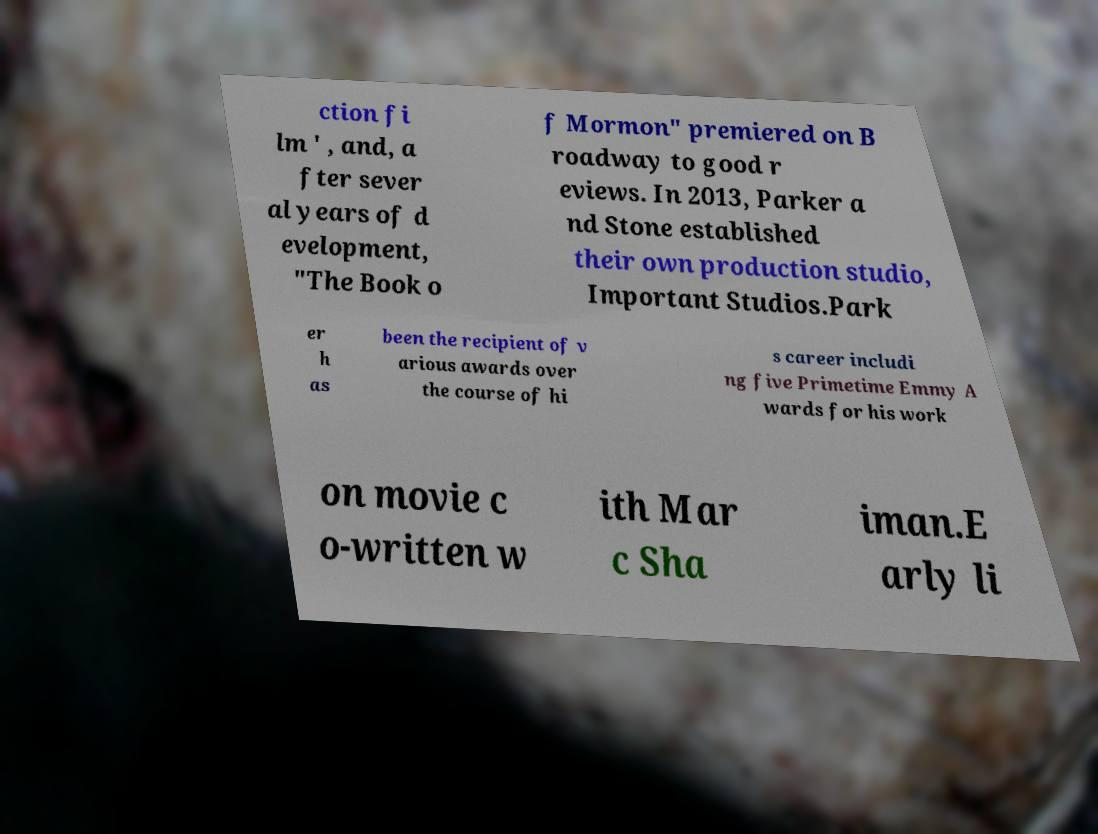Could you assist in decoding the text presented in this image and type it out clearly? ction fi lm ' , and, a fter sever al years of d evelopment, "The Book o f Mormon" premiered on B roadway to good r eviews. In 2013, Parker a nd Stone established their own production studio, Important Studios.Park er h as been the recipient of v arious awards over the course of hi s career includi ng five Primetime Emmy A wards for his work on movie c o-written w ith Mar c Sha iman.E arly li 